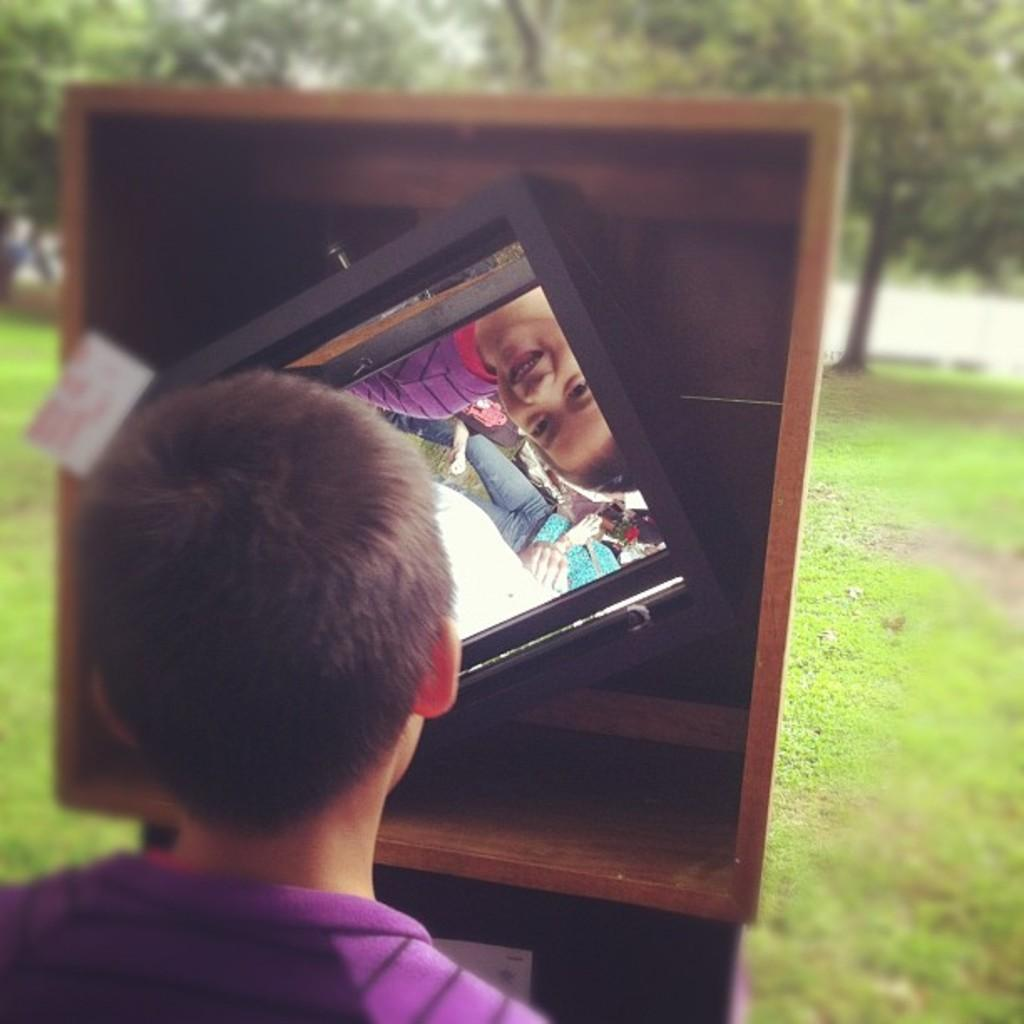Who is the main subject in the picture? There is a small boy in the picture. What is the boy doing in the picture? The boy is looking into a mirror. Where is the mirror placed in the picture? The mirror is placed on a wooden box. What can be seen in the background of the picture? There are trees visible in the background of the picture. How does the boy attack the trees in the background of the image? There is no indication in the image that the boy is attacking the trees or engaging in any aggressive behavior. 